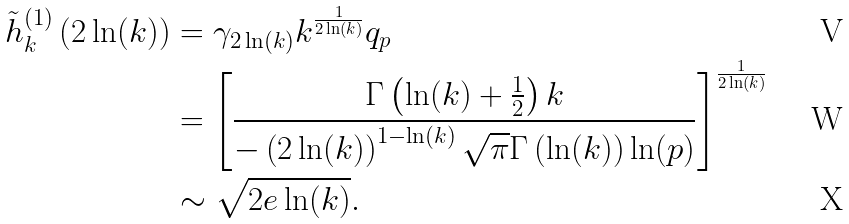<formula> <loc_0><loc_0><loc_500><loc_500>\tilde { h } _ { k } ^ { ( 1 ) } \left ( 2 \ln ( k ) \right ) & = \gamma _ { 2 \ln ( k ) } k ^ { \frac { 1 } { 2 \ln ( k ) } } q _ { p } \\ & = \left [ \frac { \Gamma \left ( \ln ( k ) + \frac { 1 } { 2 } \right ) k } { - \left ( 2 \ln ( k ) \right ) ^ { 1 - \ln ( k ) } \sqrt { \pi } \Gamma \left ( \ln ( k ) \right ) \ln ( p ) } \right ] ^ { \frac { 1 } { 2 \ln ( k ) } } \\ & \sim \sqrt { 2 e \ln ( k ) } .</formula> 